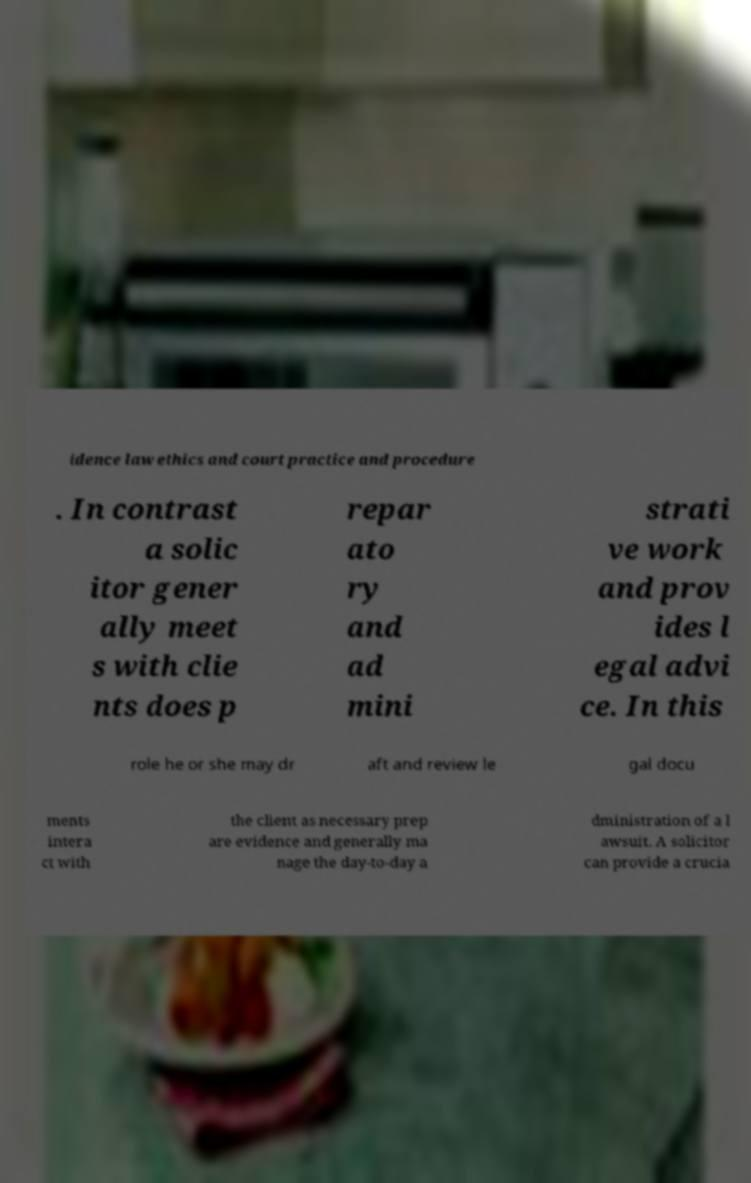I need the written content from this picture converted into text. Can you do that? idence law ethics and court practice and procedure . In contrast a solic itor gener ally meet s with clie nts does p repar ato ry and ad mini strati ve work and prov ides l egal advi ce. In this role he or she may dr aft and review le gal docu ments intera ct with the client as necessary prep are evidence and generally ma nage the day-to-day a dministration of a l awsuit. A solicitor can provide a crucia 